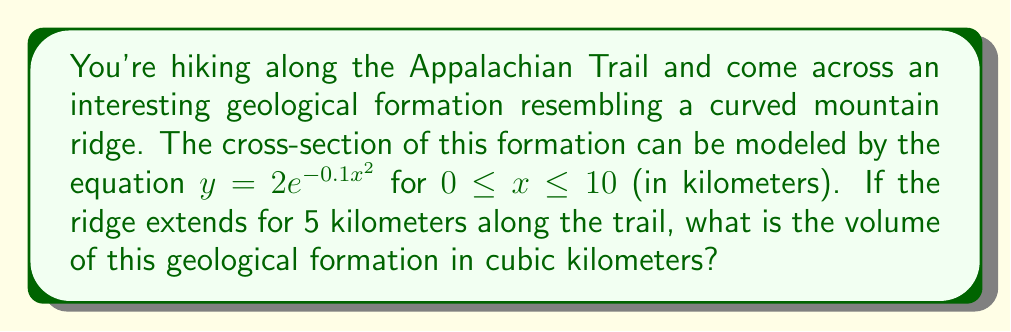Provide a solution to this math problem. To solve this problem, we'll use integration techniques from algebraic geometry. Let's approach this step-by-step:

1) The volume of the formation can be calculated using a double integral. We'll integrate the cross-section area along the length of the ridge.

2) The cross-section area at any point along the ridge is given by the integral of the function $y = 2e^{-0.1x^2}$ from 0 to 10.

3) Let's set up the double integral:

   $$V = \int_0^5 \int_0^{10} 2e^{-0.1x^2} dx dy$$

4) We can solve this by first integrating with respect to x:

   $$V = \int_0^5 \left[ -\sqrt{\frac{\pi}{0.1}} \cdot \text{erf}(\sqrt{0.1}x) \right]_0^{10} dy$$

   Where erf is the error function.

5) Evaluating the inner integral:

   $$V = \int_0^5 \left( -\sqrt{10\pi} \cdot \text{erf}(\sqrt{0.1} \cdot 10) - (-\sqrt{10\pi} \cdot \text{erf}(0)) \right) dy$$

6) Simplify:

   $$V = \int_0^5 \sqrt{10\pi} \cdot \text{erf}(\sqrt{10}) dy$$

7) The error function of $\sqrt{10}$ is approximately 0.9999779, so:

   $$V \approx \int_0^5 \sqrt{10\pi} \cdot 0.9999779 dy$$

8) This simplifies to:

   $$V \approx 5 \cdot \sqrt{10\pi} \cdot 0.9999779$$

9) Calculating this value:

   $$V \approx 28.0123 \text{ cubic kilometers}$$
Answer: $28.0123 \text{ km}^3$ 